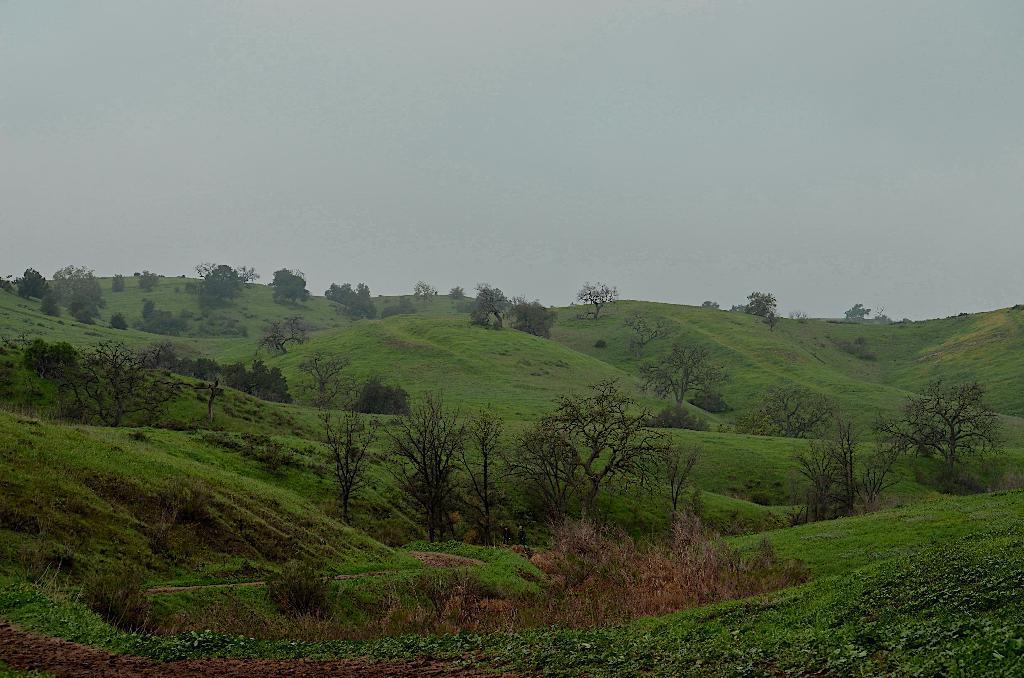In one or two sentences, can you explain what this image depicts? In this image we can see a group of trees, hill and the sky. 